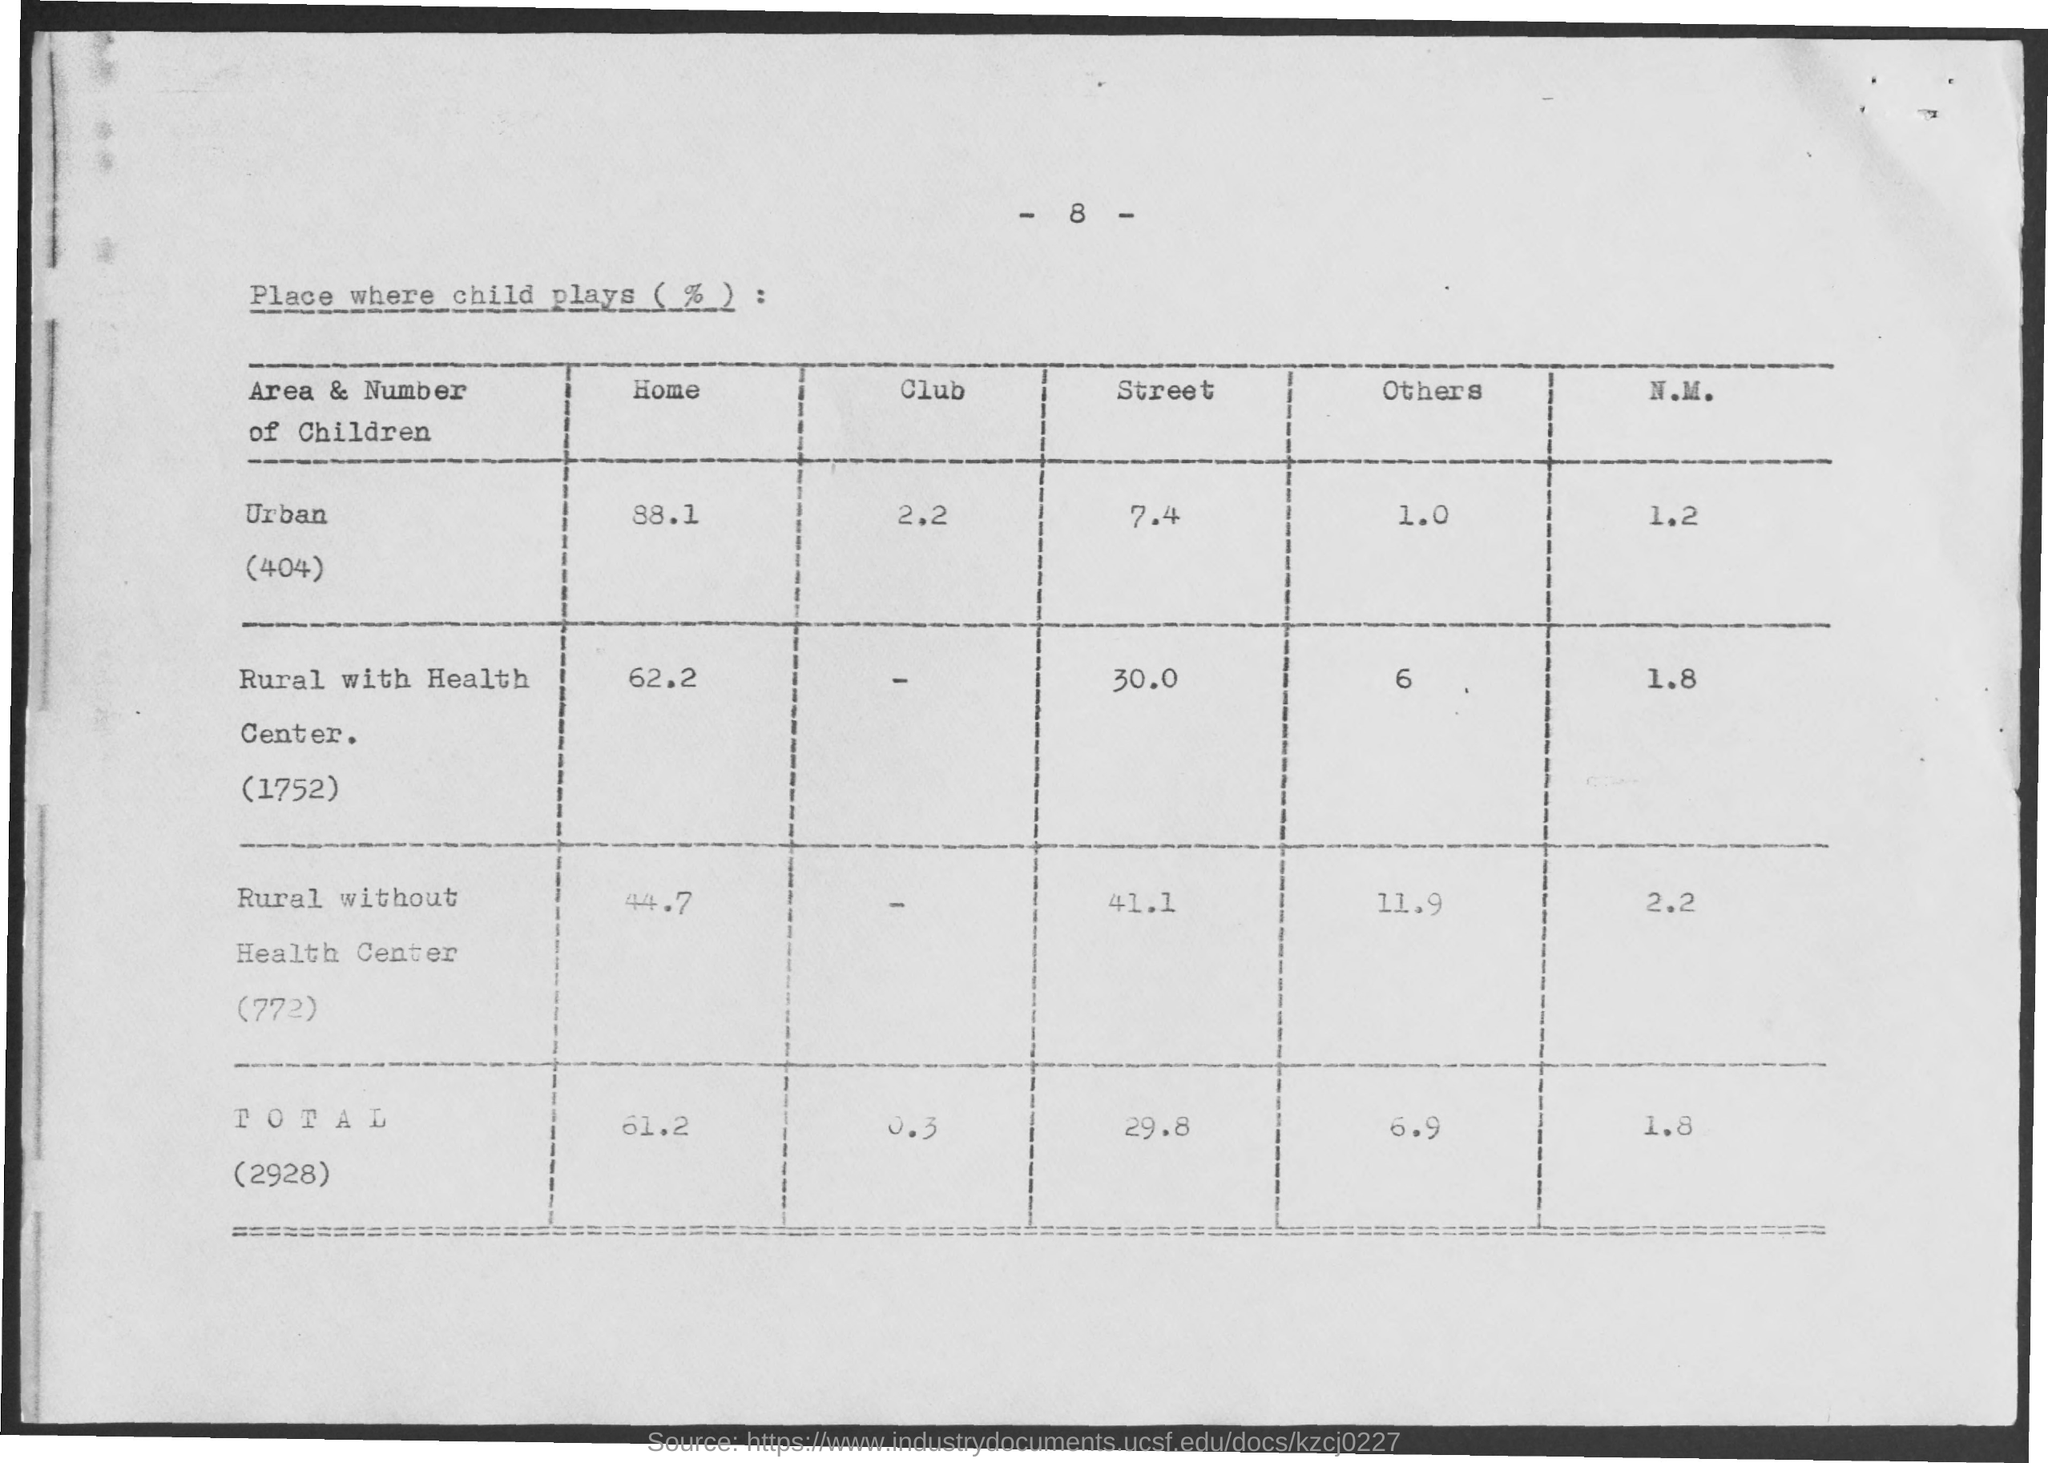What is the % of Children in Urban Area who play at Home?
Offer a very short reply. 88.1. What is the % of Children in Urban Area who play at Club?
Provide a short and direct response. 2.2. What is the % of Children in Urban Area who play at Street?
Offer a very short reply. 7.4. What is the % of Children in Urban Area who play at others?
Offer a terse response. 1.0. What is the % of Children in Urban Area who play at N.M.?
Make the answer very short. 1.2. What is the % of Children in Rural with Health Center (1752) who play at Home?
Your response must be concise. 62.2. What is the % of Children in Rural with Health Center (1752) who play at Street?
Offer a terse response. 30.0. What is the % of Children in Rural with Health Center (1752) who play at Others?
Provide a short and direct response. 6. What is the % of Children in Rural with Health Center (1752) who play at N.M.?
Provide a succinct answer. 1.8. What is the % of Children in Rural without Health Center who play at Home?
Give a very brief answer. 44.7. 